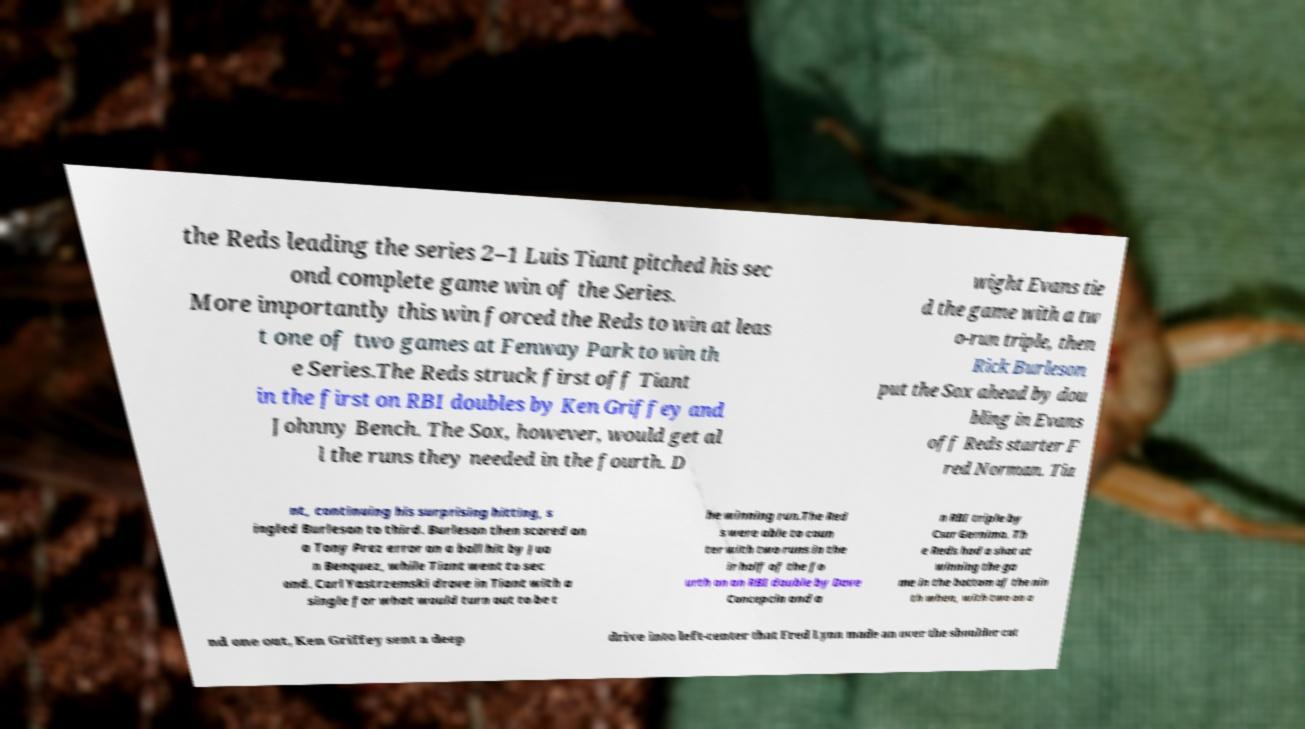Can you read and provide the text displayed in the image?This photo seems to have some interesting text. Can you extract and type it out for me? the Reds leading the series 2–1 Luis Tiant pitched his sec ond complete game win of the Series. More importantly this win forced the Reds to win at leas t one of two games at Fenway Park to win th e Series.The Reds struck first off Tiant in the first on RBI doubles by Ken Griffey and Johnny Bench. The Sox, however, would get al l the runs they needed in the fourth. D wight Evans tie d the game with a tw o-run triple, then Rick Burleson put the Sox ahead by dou bling in Evans off Reds starter F red Norman. Tia nt, continuing his surprising hitting, s ingled Burleson to third. Burleson then scored on a Tony Prez error on a ball hit by Jua n Benquez, while Tiant went to sec ond. Carl Yastrzemski drove in Tiant with a single for what would turn out to be t he winning run.The Red s were able to coun ter with two runs in the ir half of the fo urth on an RBI double by Dave Concepcin and a n RBI triple by Csar Gernimo. Th e Reds had a shot at winning the ga me in the bottom of the nin th when, with two on a nd one out, Ken Griffey sent a deep drive into left-center that Fred Lynn made an over the shoulder cat 